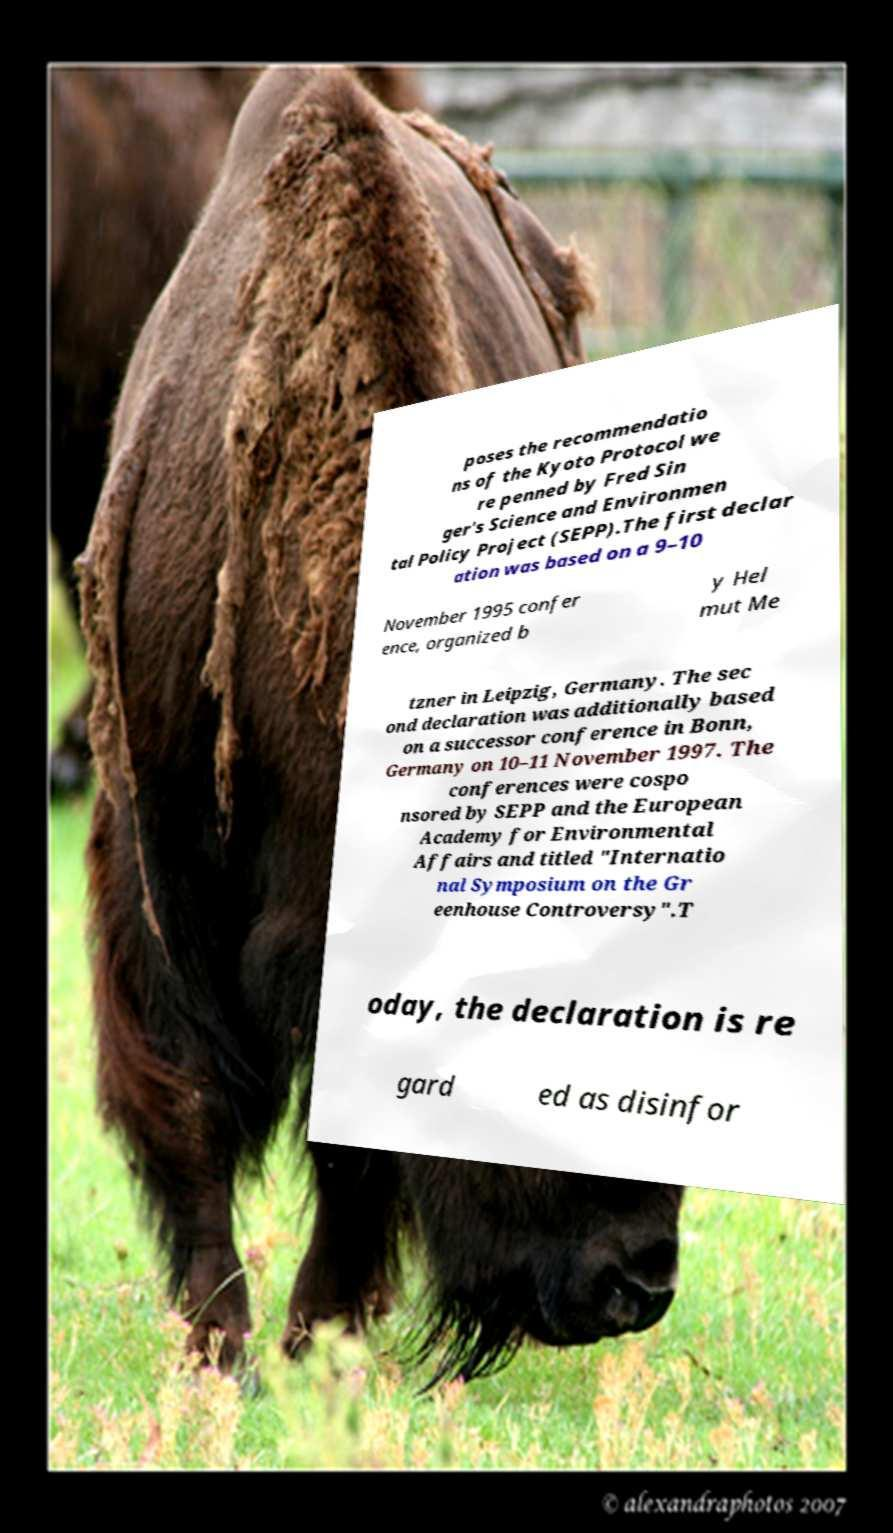Can you accurately transcribe the text from the provided image for me? poses the recommendatio ns of the Kyoto Protocol we re penned by Fred Sin ger's Science and Environmen tal Policy Project (SEPP).The first declar ation was based on a 9–10 November 1995 confer ence, organized b y Hel mut Me tzner in Leipzig, Germany. The sec ond declaration was additionally based on a successor conference in Bonn, Germany on 10–11 November 1997. The conferences were cospo nsored by SEPP and the European Academy for Environmental Affairs and titled "Internatio nal Symposium on the Gr eenhouse Controversy".T oday, the declaration is re gard ed as disinfor 